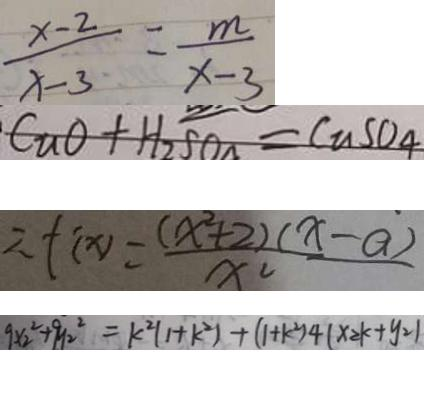Convert formula to latex. <formula><loc_0><loc_0><loc_500><loc_500>\frac { x - 2 } { x - 3 } = \frac { m } { x - 3 } 
 C u O + H _ { 2 } S O _ { 4 } = C u S O _ { 4 } 
 \therefore f ( x ) = \frac { ( x ^ { 2 } + 2 ) ( x - a ) } { x ^ { 2 } } 
 9 x _ { 2 } ^ { 2 } + 9 y _ { 2 } ^ { 2 } = k ^ { 2 } ( 1 + k ^ { 2 } ) + ( 1 + k ^ { 2 } ) 4 ( x _ { 2 } k + y _ { 2 } )</formula> 